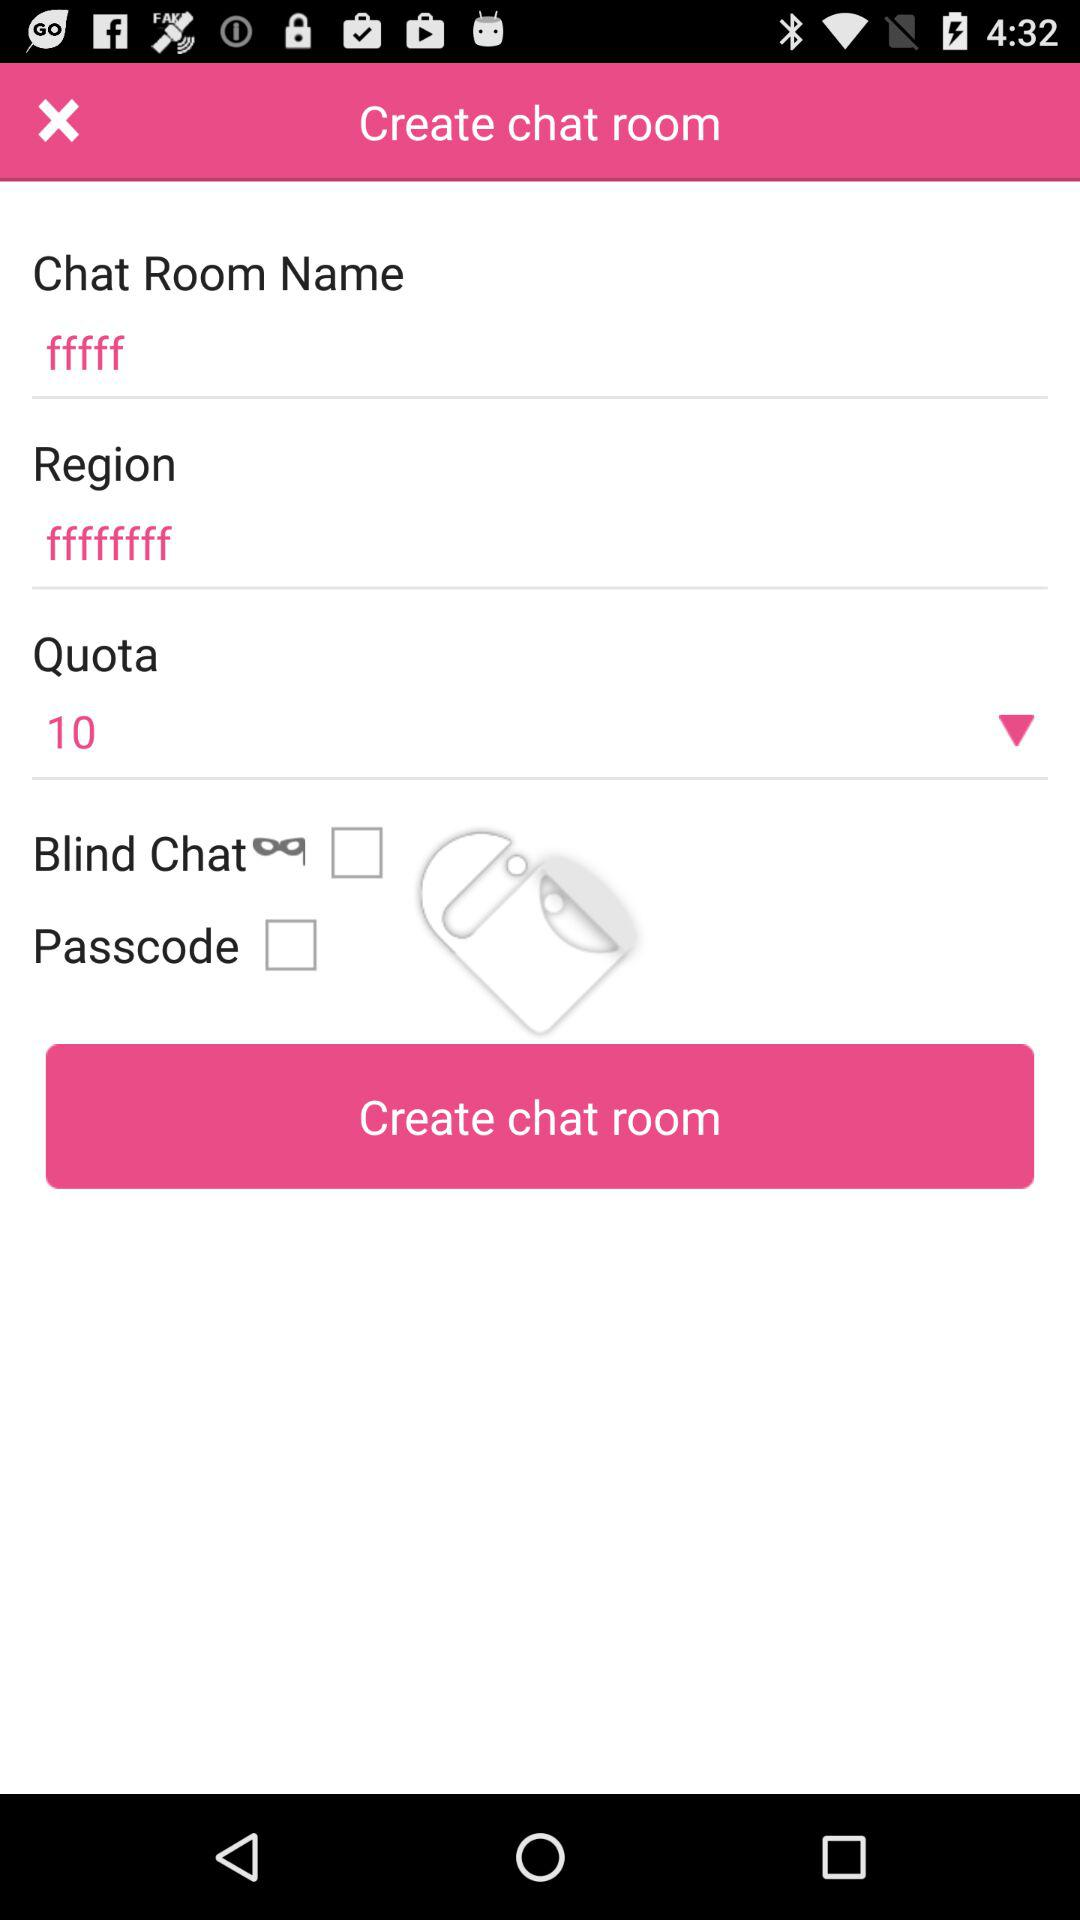How many check boxes are there on the screen?
Answer the question using a single word or phrase. 2 